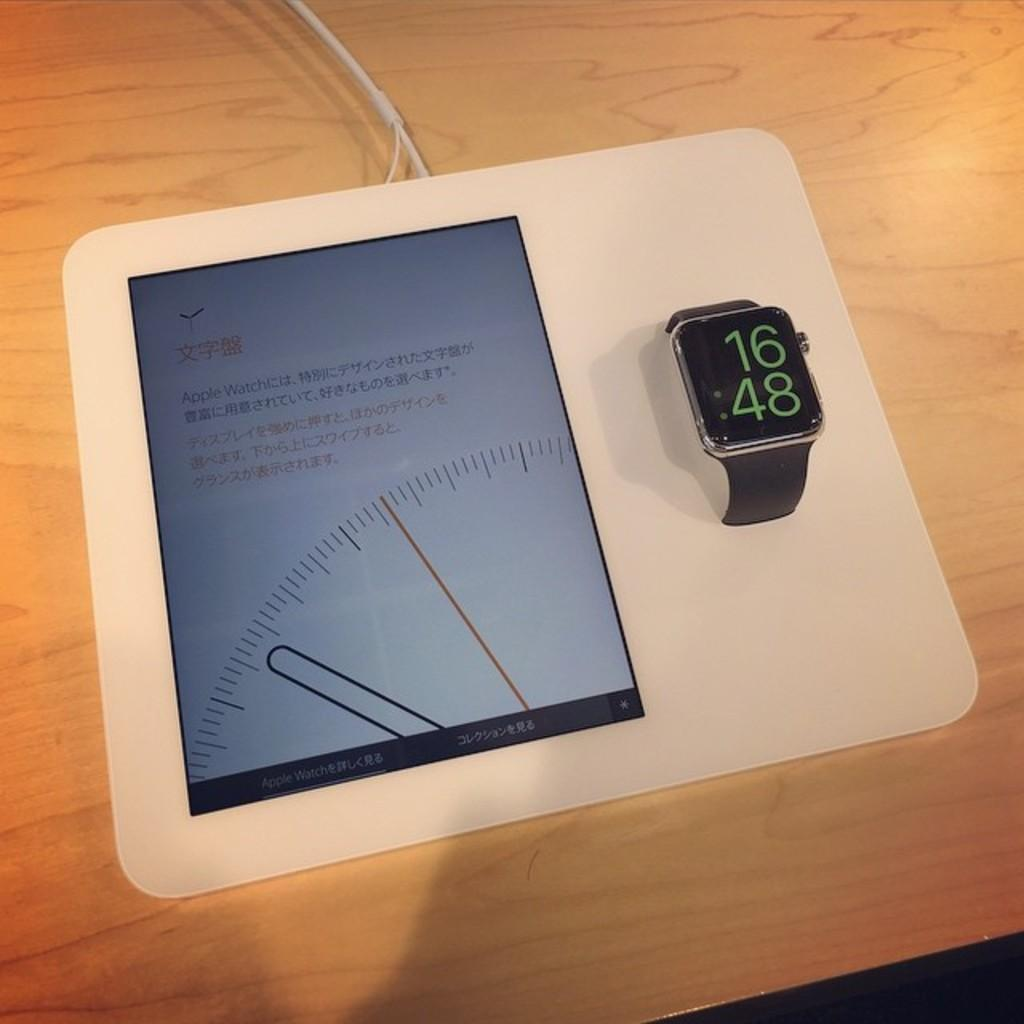<image>
Render a clear and concise summary of the photo. smartwatch that says 16:48 and has a measuring wavelength tool on the left. 